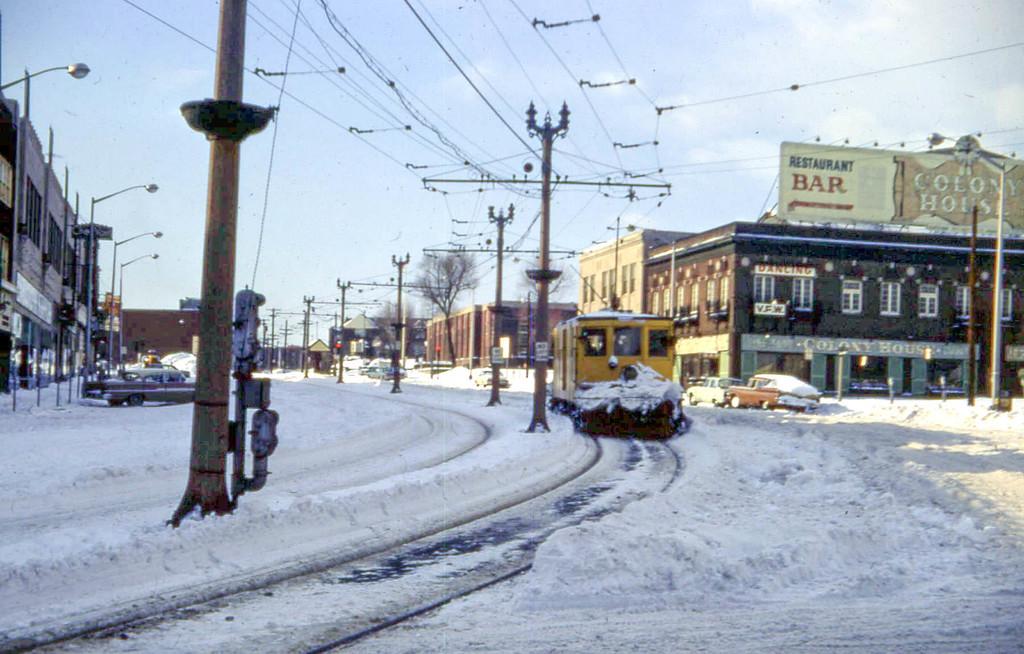What is the name of the bar?
Ensure brevity in your answer.  Colony house. What kind of store is being displayed?
Keep it short and to the point. Bar. 